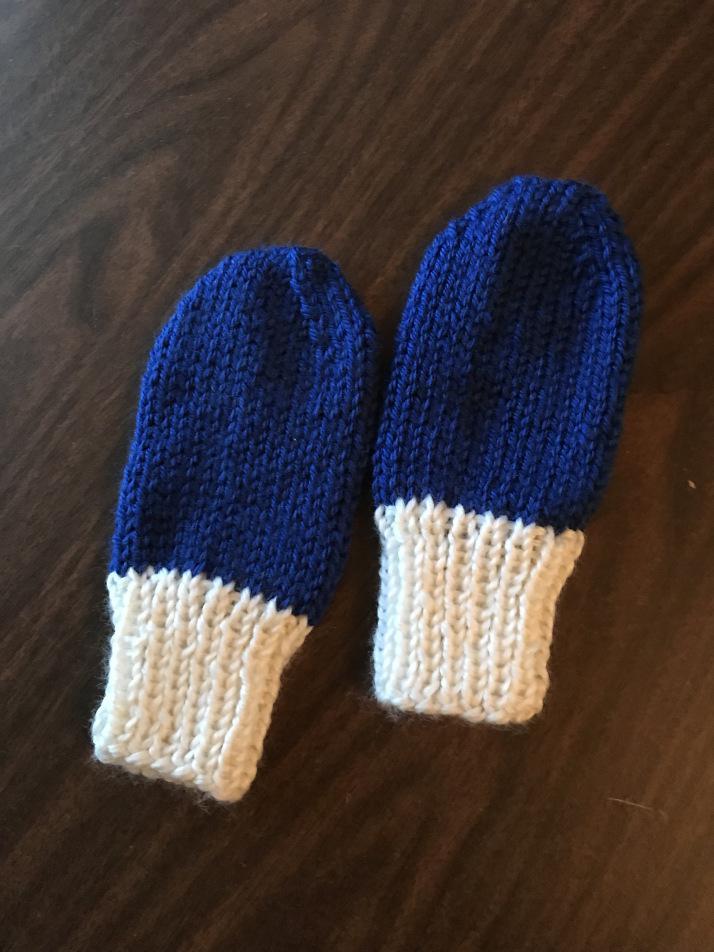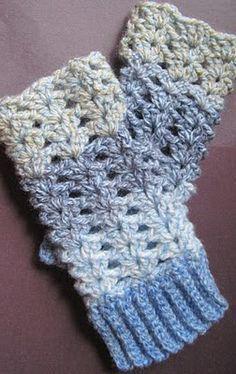The first image is the image on the left, the second image is the image on the right. Given the left and right images, does the statement "Both pairs of mittens are different shades of the same colors." hold true? Answer yes or no. Yes. 